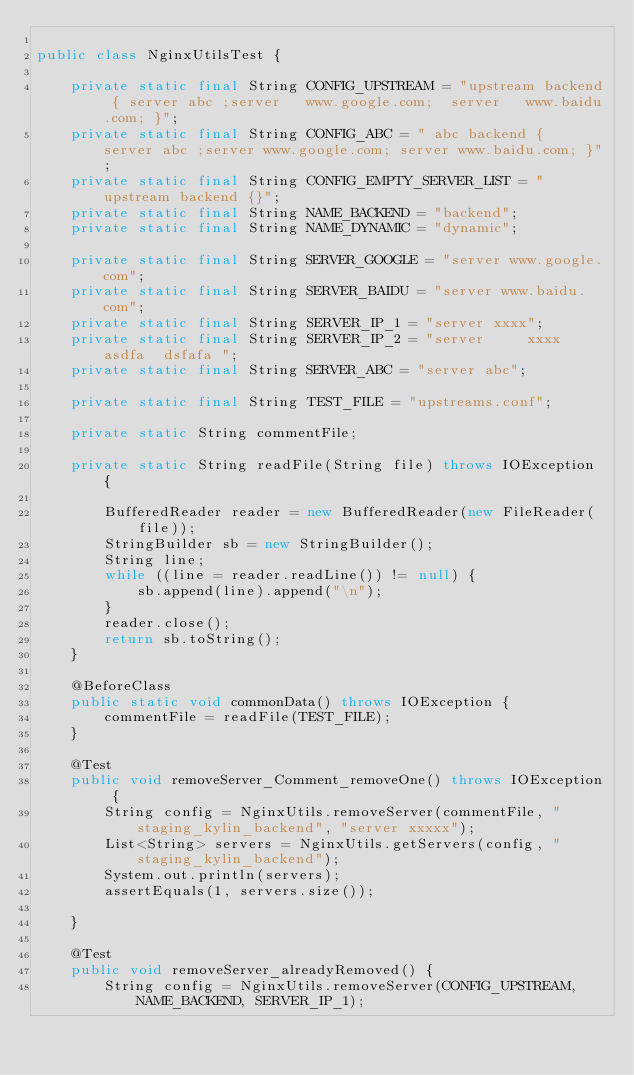<code> <loc_0><loc_0><loc_500><loc_500><_Java_>
public class NginxUtilsTest {

    private static final String CONFIG_UPSTREAM = "upstream backend { server abc ;server   www.google.com;  server   www.baidu.com; }";
    private static final String CONFIG_ABC = " abc backend {  server abc ;server www.google.com; server www.baidu.com; }";
    private static final String CONFIG_EMPTY_SERVER_LIST = " upstream backend {}";
    private static final String NAME_BACKEND = "backend";
    private static final String NAME_DYNAMIC = "dynamic";

    private static final String SERVER_GOOGLE = "server www.google.com";
    private static final String SERVER_BAIDU = "server www.baidu.com";
    private static final String SERVER_IP_1 = "server xxxx";
    private static final String SERVER_IP_2 = "server     xxxx   asdfa  dsfafa ";
    private static final String SERVER_ABC = "server abc";

    private static final String TEST_FILE = "upstreams.conf";

    private static String commentFile;

    private static String readFile(String file) throws IOException {

        BufferedReader reader = new BufferedReader(new FileReader(file));
        StringBuilder sb = new StringBuilder();
        String line;
        while ((line = reader.readLine()) != null) {
            sb.append(line).append("\n");
        }
        reader.close();
        return sb.toString();
    }

    @BeforeClass
    public static void commonData() throws IOException {
        commentFile = readFile(TEST_FILE);
    }

    @Test
    public void removeServer_Comment_removeOne() throws IOException {
        String config = NginxUtils.removeServer(commentFile, "staging_kylin_backend", "server xxxxx");
        List<String> servers = NginxUtils.getServers(config, "staging_kylin_backend");
        System.out.println(servers);
        assertEquals(1, servers.size());

    }

    @Test
    public void removeServer_alreadyRemoved() {
        String config = NginxUtils.removeServer(CONFIG_UPSTREAM, NAME_BACKEND, SERVER_IP_1);</code> 